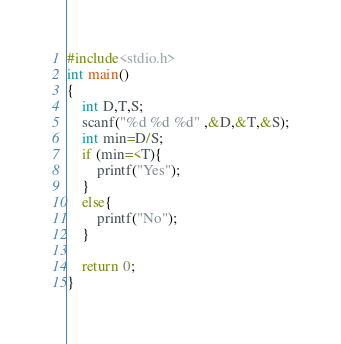<code> <loc_0><loc_0><loc_500><loc_500><_C_>#include<stdio.h>
int main()
{
    int D,T,S;
    scanf("%d %d %d" ,&D,&T,&S);
    int min=D/S;
    if (min=<T){
        printf("Yes");
    }
    else{
        printf("No");
    }

    return 0;
}</code> 